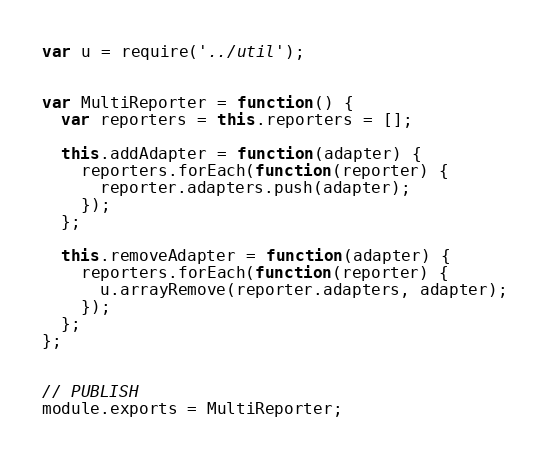Convert code to text. <code><loc_0><loc_0><loc_500><loc_500><_JavaScript_>var u = require('../util');


var MultiReporter = function() {
  var reporters = this.reporters = [];

  this.addAdapter = function(adapter) {
    reporters.forEach(function(reporter) {
      reporter.adapters.push(adapter);
    });
  };

  this.removeAdapter = function(adapter) {
    reporters.forEach(function(reporter) {
      u.arrayRemove(reporter.adapters, adapter);
    });
  };
};


// PUBLISH
module.exports = MultiReporter;
</code> 